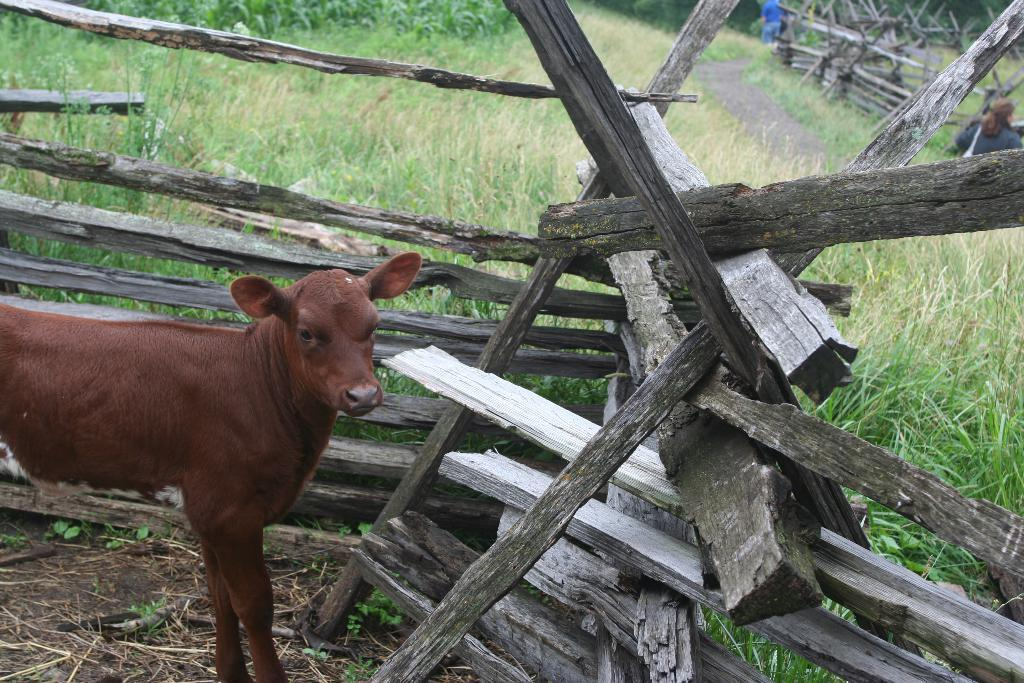What type of animal can be seen in the image? There is an animal in the image, but its specific type cannot be determined from the provided facts. Where is the animal located in the image? The animal is on a surface in the image. What can be seen in the background of the image? There is a wooden fence and green grass in the image. Are there any people visible in the image? Yes, there are people on the right side of the image. What type of pie is being served to the animal in the image? There is no pie present in the image, and the animal is not being served any food. 